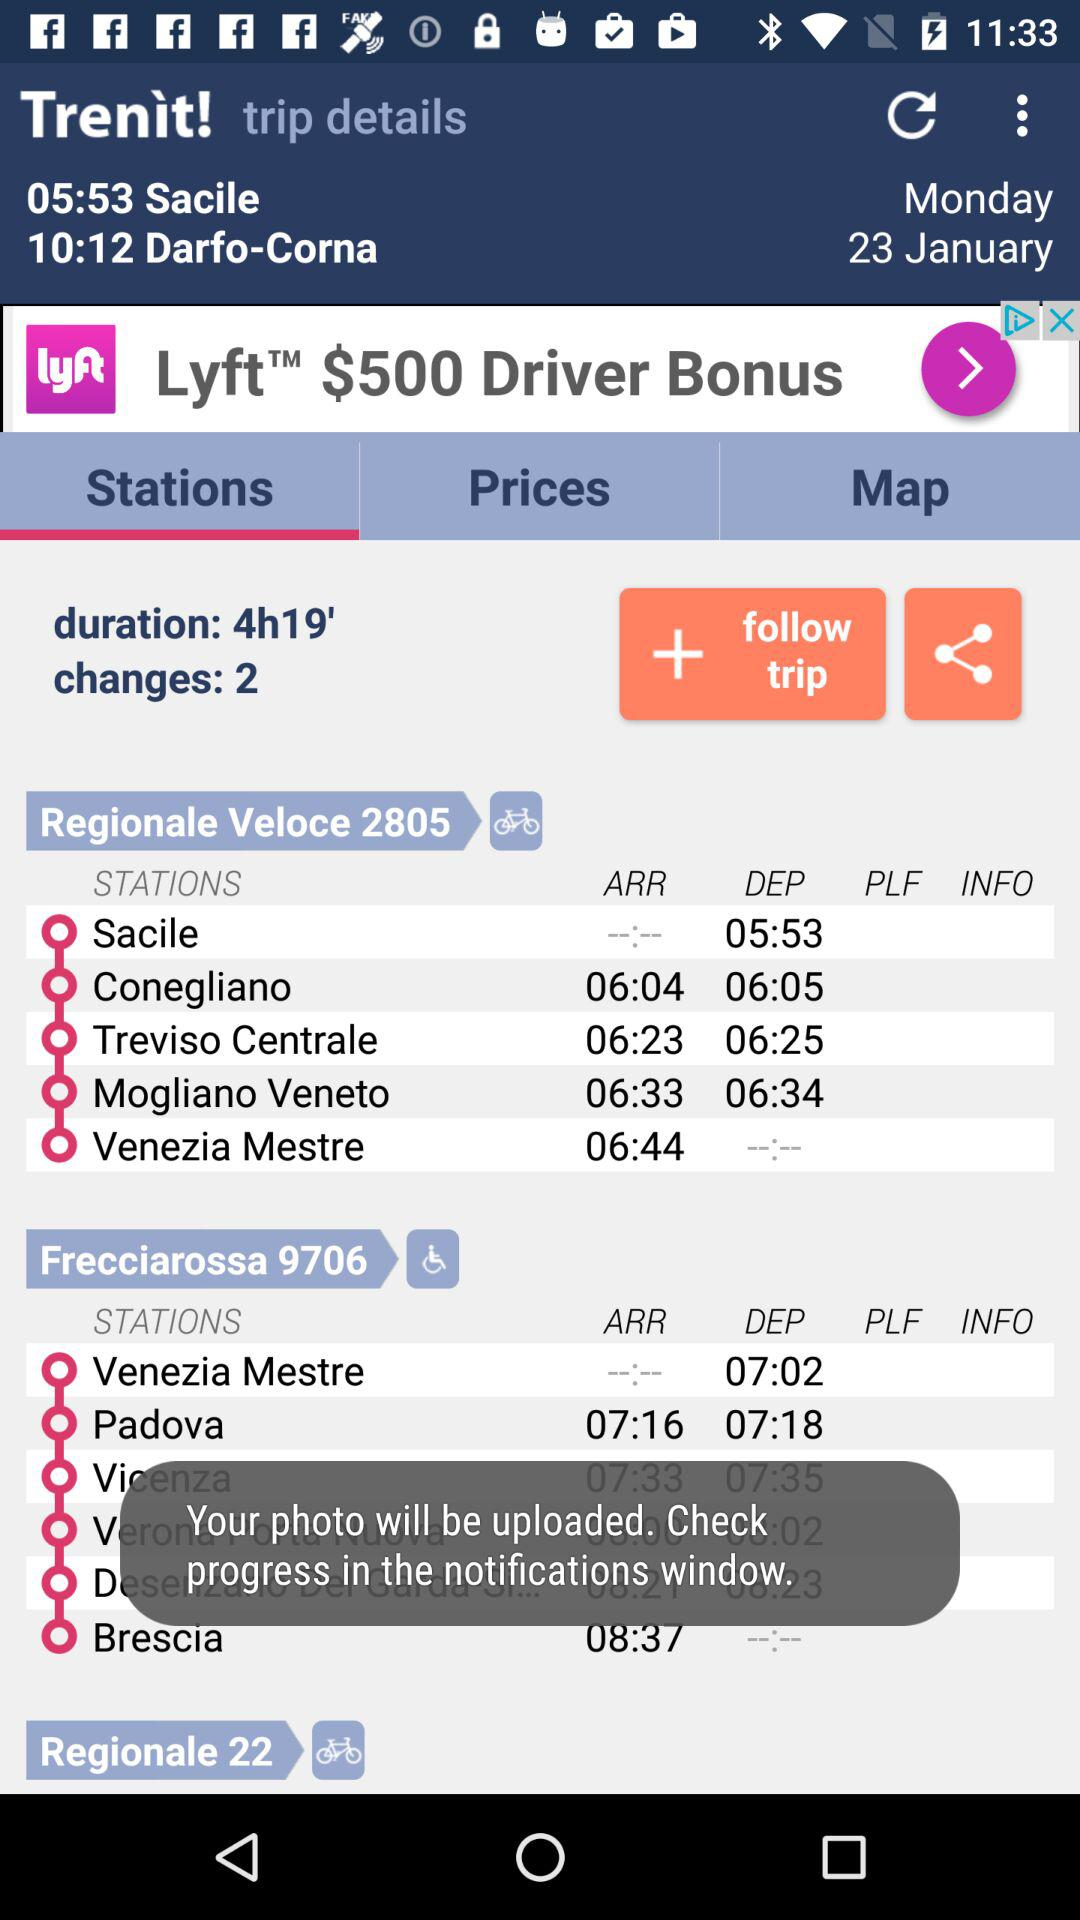How many changes are there on this trip?
Answer the question using a single word or phrase. 2 